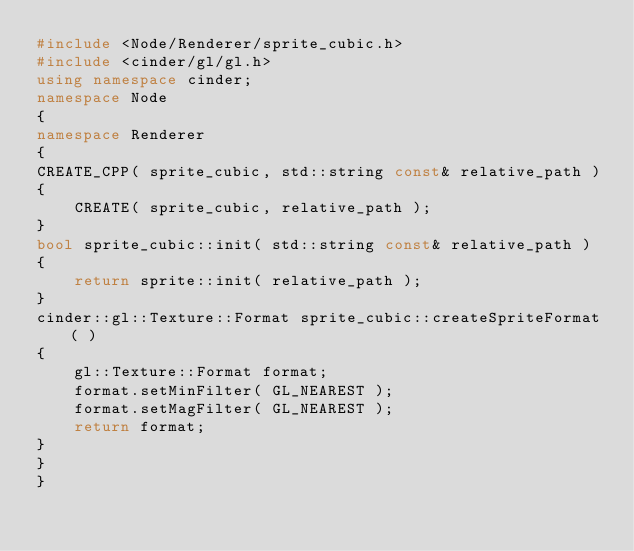Convert code to text. <code><loc_0><loc_0><loc_500><loc_500><_C++_>#include <Node/Renderer/sprite_cubic.h>
#include <cinder/gl/gl.h>
using namespace cinder;
namespace Node
{
namespace Renderer
{
CREATE_CPP( sprite_cubic, std::string const& relative_path )
{
    CREATE( sprite_cubic, relative_path );
}
bool sprite_cubic::init( std::string const& relative_path )
{
    return sprite::init( relative_path );
}
cinder::gl::Texture::Format sprite_cubic::createSpriteFormat( )
{
    gl::Texture::Format format;
    format.setMinFilter( GL_NEAREST );
    format.setMagFilter( GL_NEAREST );
    return format;
}
}
}</code> 